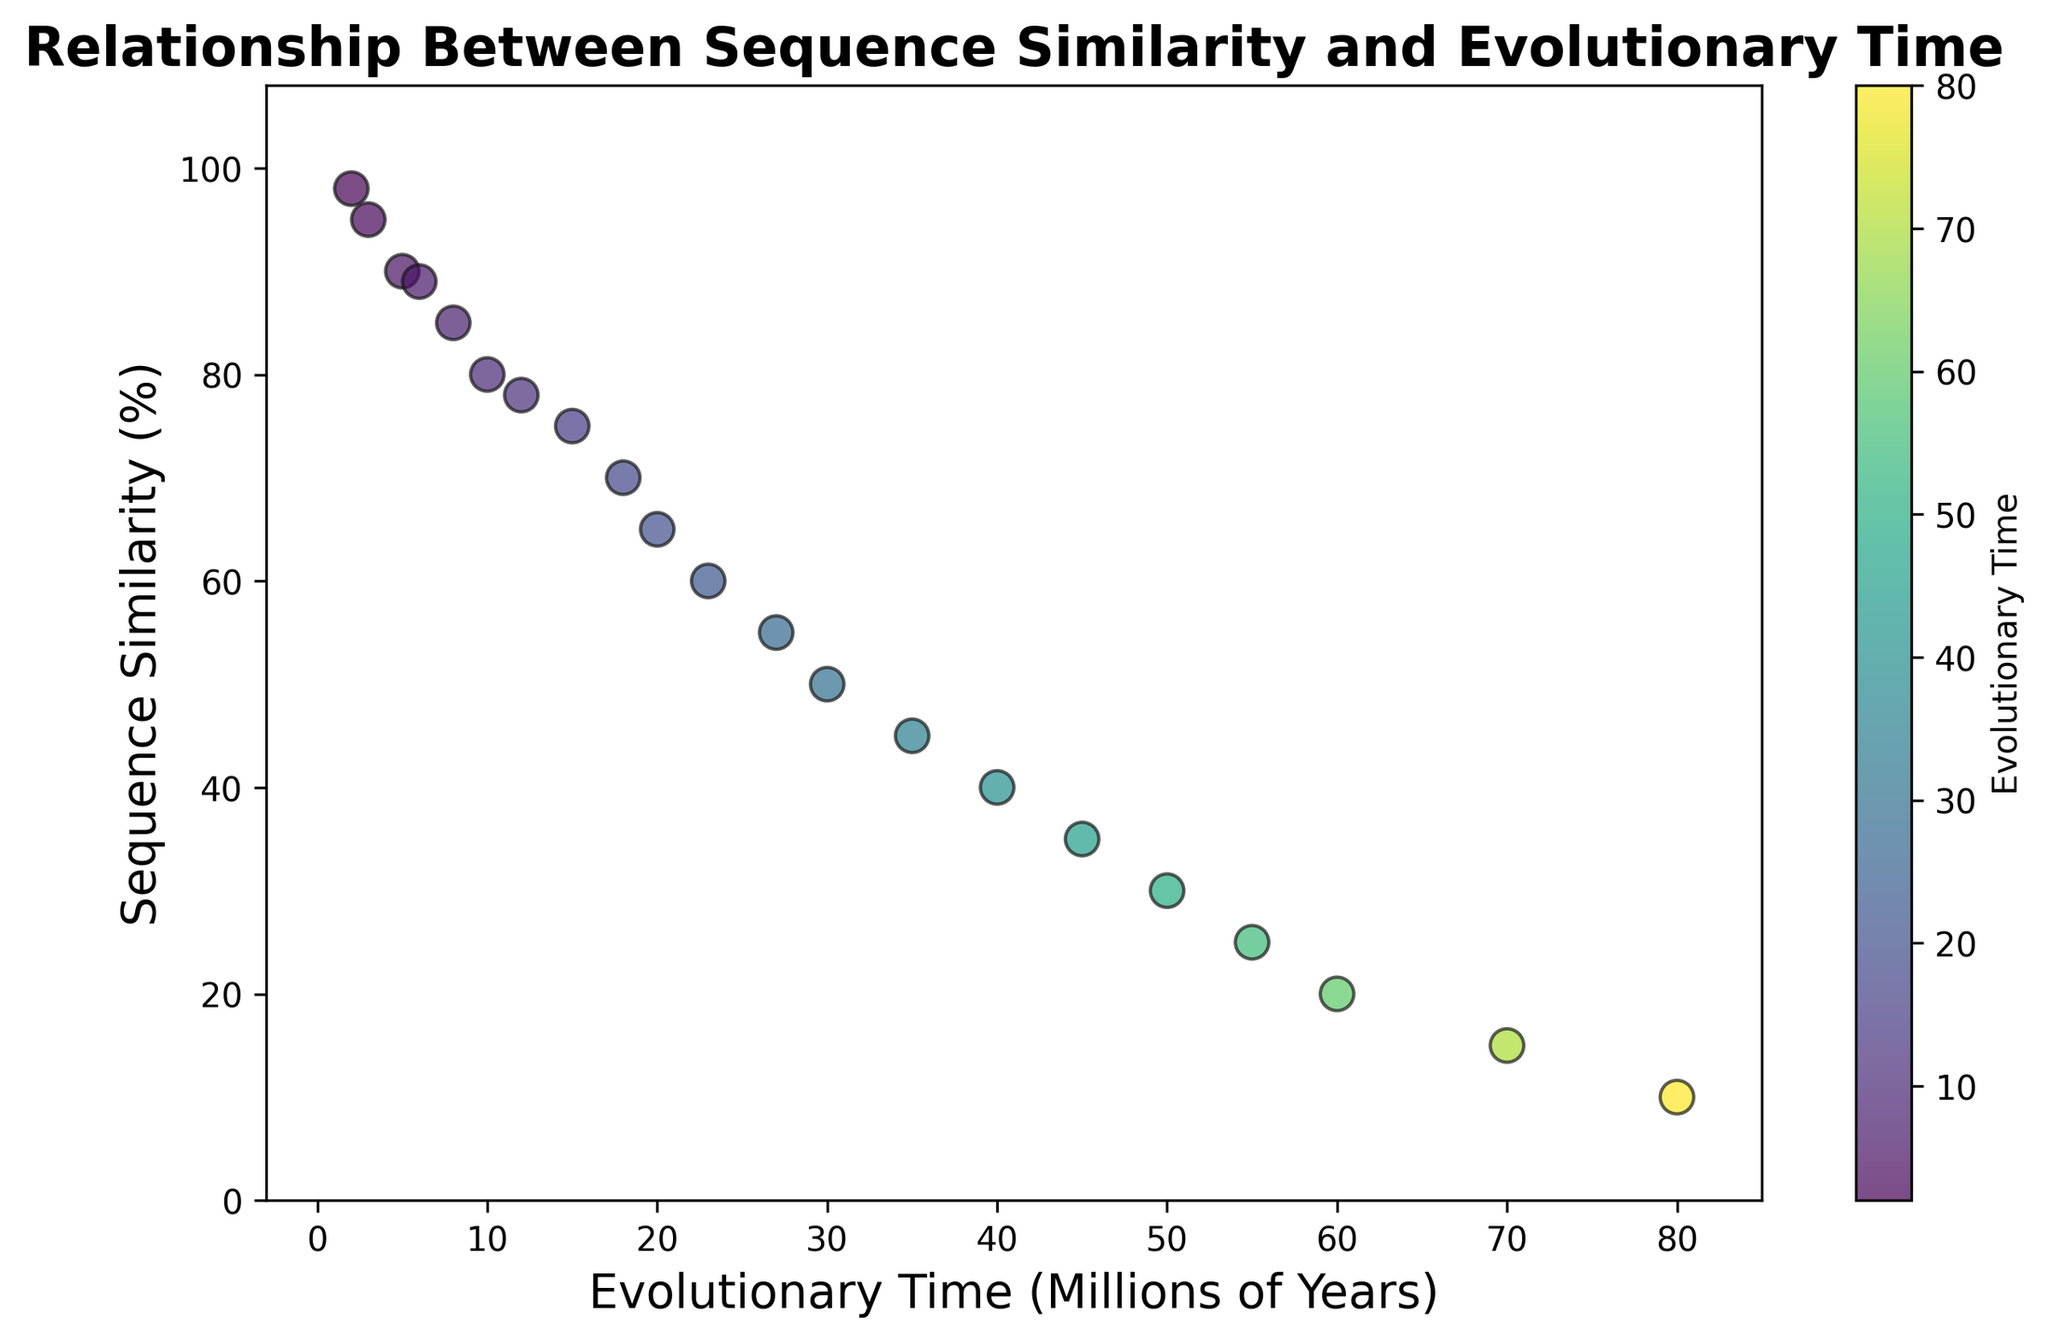what is the pattern between sequence similarity and evolutionary time? By examining the scatter plot, it's evident that sequence similarity decreases as evolutionary time increases. This is shown by the downward trend of the data points from left to right.
Answer: Sequence similarity decreases as evolutionary time increases What is the sequence similarity when evolutionary time is around 15 million years? From the scatter plot, locate the point where the evolutionary time is approximately 15 million years. The corresponding sequence similarity value near this point is 75%.
Answer: 75% Is there any color change across the evolutionary time domain? The scatter plot uses a color gradient (from blue to green) to represent different evolutionary times. Lighter colors represent lower evolutionary times, while darker colors represent higher evolutionary times.
Answer: Yes, from blue to green What is the sum of sequence similarities when evolutionary time is 5 million years and 25 million years respectively? From the scatter plot, read the sequence similarity values at evolutionary times 5 million years (90%) and 25 million years (60%). Summing these values: 90 + 60 = 150.
Answer: 150 Does sequence similarity drop more rapidly at lower or higher evolutionary times based on the scatter plot? The scatter plot's trend shows that sequence similarity drops more rapidly at lower evolutionary times (evidenced by the steeper decline in the early range) compared to a more gradual decline at higher evolutionary times.
Answer: Lower evolutionary times Compare the lowest and highest sequence similarity values. The lowest sequence similarity value is 10% and the highest is 98%, as indicated by the scatter plot's vertical range.
Answer: 10% and 98% At what evolutionary time does sequence similarity drop to 50%? By observing the scatter plot, sequence similarity drops to 50% at around 30 million years evolutionary time.
Answer: 30 million years How does the range of sequence similarity values change over the range of evolutionary times? Initially, sequence similarity values exhibit a wide range and are relatively high. As evolutionary time increases, the range narrows and sequence similarity values generally decrease. This indicates a broad spread at lower evolutionary times, becoming more constrained at higher evolutionary times.
Answer: Narrows and decreases 